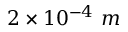Convert formula to latex. <formula><loc_0><loc_0><loc_500><loc_500>2 \times 1 0 ^ { - 4 } m</formula> 